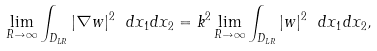Convert formula to latex. <formula><loc_0><loc_0><loc_500><loc_500>\lim _ { R \to \infty } \int _ { D _ { L R } } | \nabla w | ^ { 2 } \ d x _ { 1 } d x _ { 2 } = k ^ { 2 } \lim _ { R \to \infty } \int _ { D _ { L R } } | w | ^ { 2 } \ d x _ { 1 } d x _ { 2 } ,</formula> 